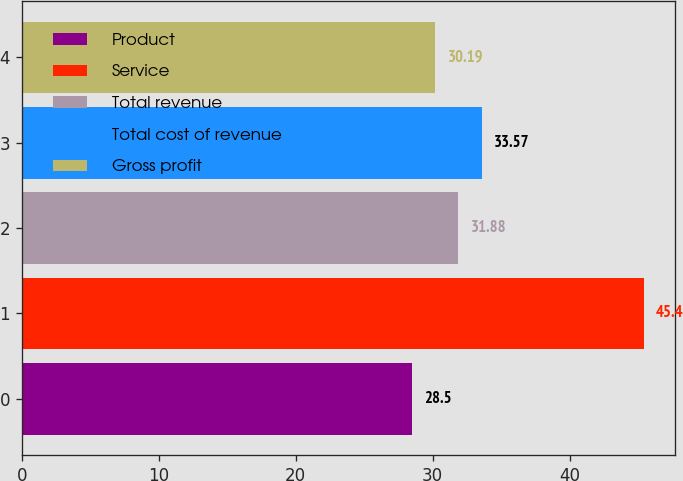<chart> <loc_0><loc_0><loc_500><loc_500><bar_chart><fcel>Product<fcel>Service<fcel>Total revenue<fcel>Total cost of revenue<fcel>Gross profit<nl><fcel>28.5<fcel>45.4<fcel>31.88<fcel>33.57<fcel>30.19<nl></chart> 